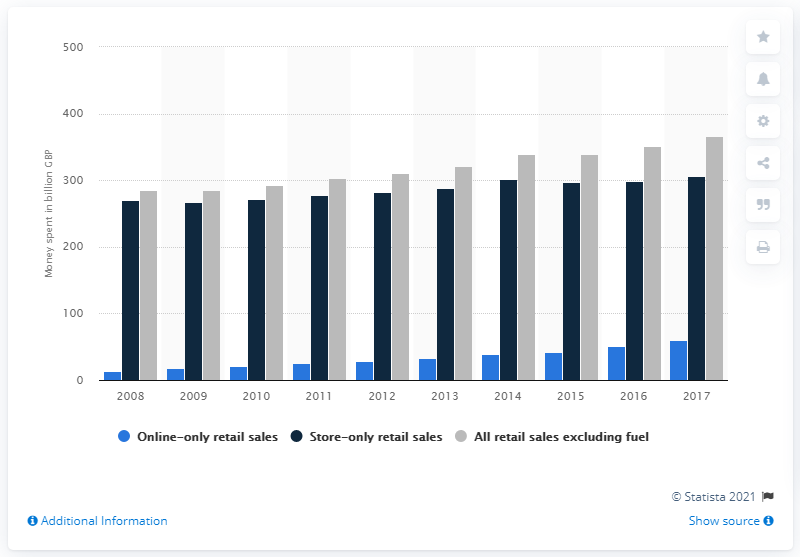Highlight a few significant elements in this photo. Since 2008, online-only sales have grown significantly. 